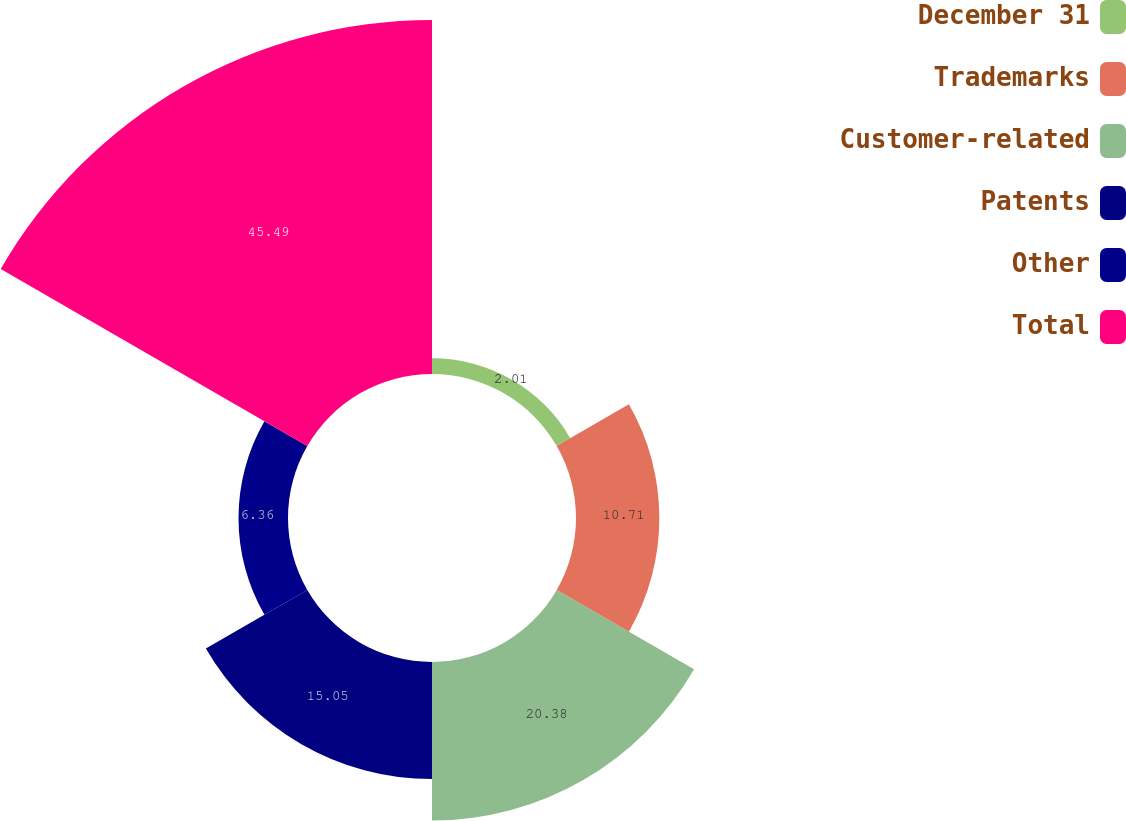Convert chart. <chart><loc_0><loc_0><loc_500><loc_500><pie_chart><fcel>December 31<fcel>Trademarks<fcel>Customer-related<fcel>Patents<fcel>Other<fcel>Total<nl><fcel>2.01%<fcel>10.71%<fcel>20.38%<fcel>15.05%<fcel>6.36%<fcel>45.49%<nl></chart> 